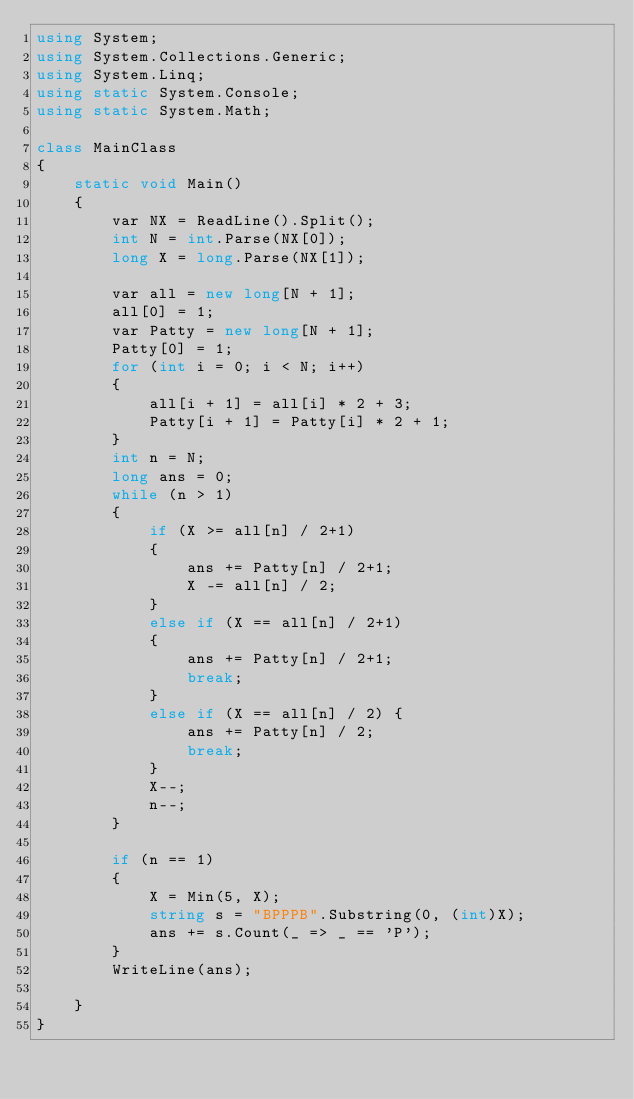<code> <loc_0><loc_0><loc_500><loc_500><_C#_>using System;
using System.Collections.Generic;
using System.Linq;
using static System.Console;
using static System.Math;

class MainClass
{
    static void Main()
    {
        var NX = ReadLine().Split();
        int N = int.Parse(NX[0]);
        long X = long.Parse(NX[1]);

        var all = new long[N + 1];
        all[0] = 1;
        var Patty = new long[N + 1];
        Patty[0] = 1;
        for (int i = 0; i < N; i++)
        {
            all[i + 1] = all[i] * 2 + 3;
            Patty[i + 1] = Patty[i] * 2 + 1;
        }
        int n = N;
        long ans = 0;
        while (n > 1)
        {
            if (X >= all[n] / 2+1)
            {
                ans += Patty[n] / 2+1;
                X -= all[n] / 2;
            }
            else if (X == all[n] / 2+1)
            {
                ans += Patty[n] / 2+1;
                break;
            }
            else if (X == all[n] / 2) {
                ans += Patty[n] / 2;
                break;
            }
            X--;
            n--;
        }
        
        if (n == 1)
        {
            X = Min(5, X);
            string s = "BPPPB".Substring(0, (int)X);
            ans += s.Count(_ => _ == 'P');
        }
        WriteLine(ans);
        
    }
}
</code> 